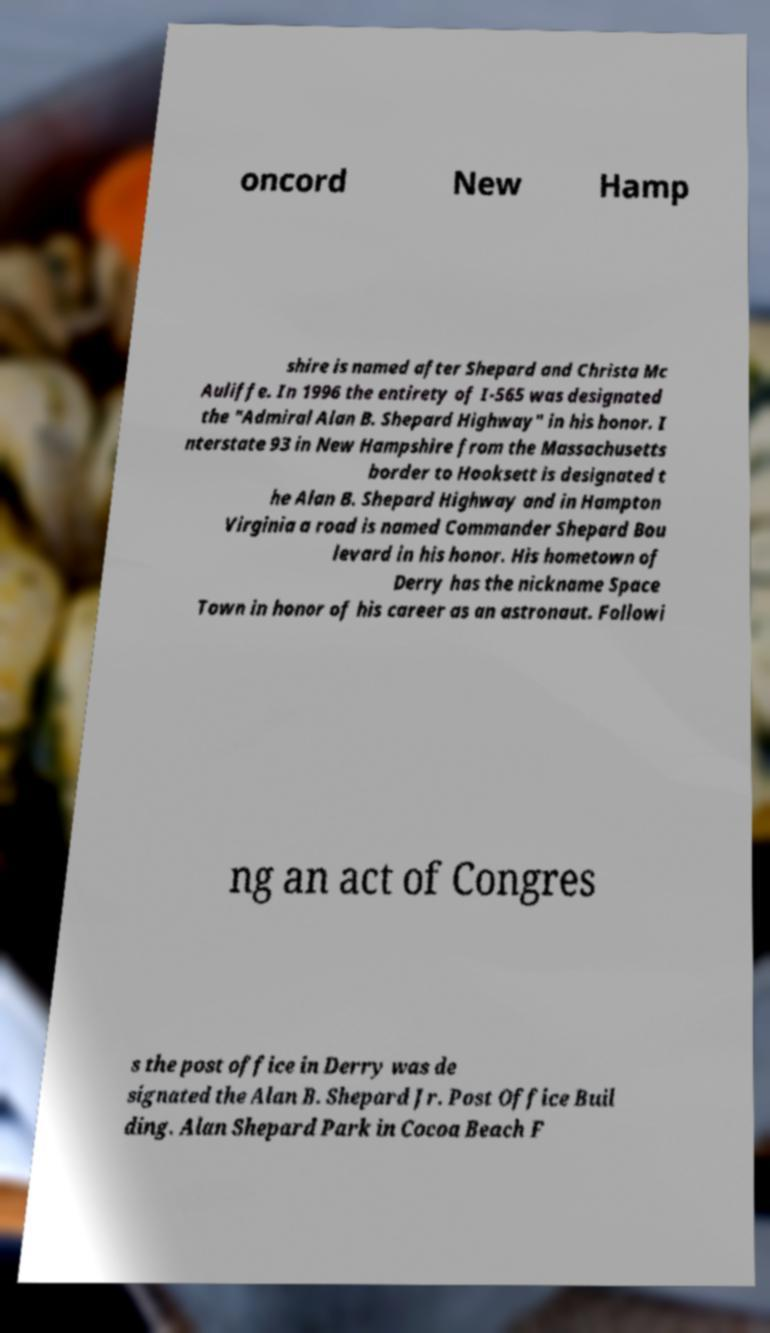What messages or text are displayed in this image? I need them in a readable, typed format. oncord New Hamp shire is named after Shepard and Christa Mc Auliffe. In 1996 the entirety of I-565 was designated the "Admiral Alan B. Shepard Highway" in his honor. I nterstate 93 in New Hampshire from the Massachusetts border to Hooksett is designated t he Alan B. Shepard Highway and in Hampton Virginia a road is named Commander Shepard Bou levard in his honor. His hometown of Derry has the nickname Space Town in honor of his career as an astronaut. Followi ng an act of Congres s the post office in Derry was de signated the Alan B. Shepard Jr. Post Office Buil ding. Alan Shepard Park in Cocoa Beach F 